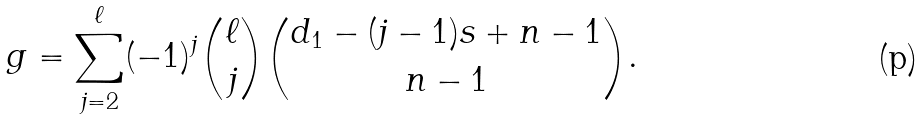<formula> <loc_0><loc_0><loc_500><loc_500>g = \sum _ { j = 2 } ^ { \ell } ( - 1 ) ^ { j } \binom { \ell } { j } \binom { d _ { 1 } - ( j - 1 ) s + n - 1 } { n - 1 } .</formula> 